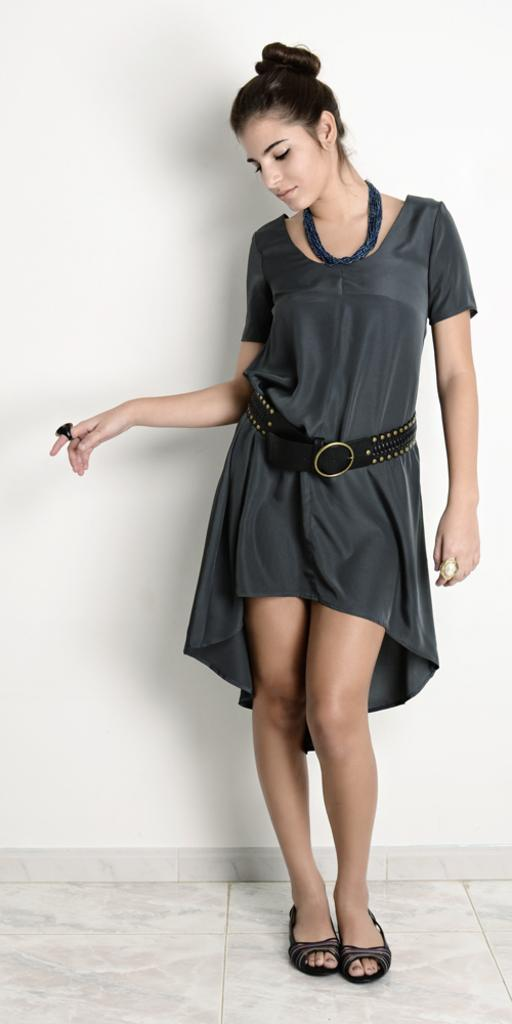Who is present in the image? There is a woman in the image. What is the woman doing in the image? The woman is standing on the floor. What can be seen in the background of the image? There is a wall in the background of the image. What is the color of the wall? The wall is white in color. What type of wing is attached to the woman in the image? There is no wing attached to the woman in the image. What kind of popcorn is being served in the class depicted in the image? There is no class or popcorn present in the image; it features a woman standing on the floor with a white wall in the background. 